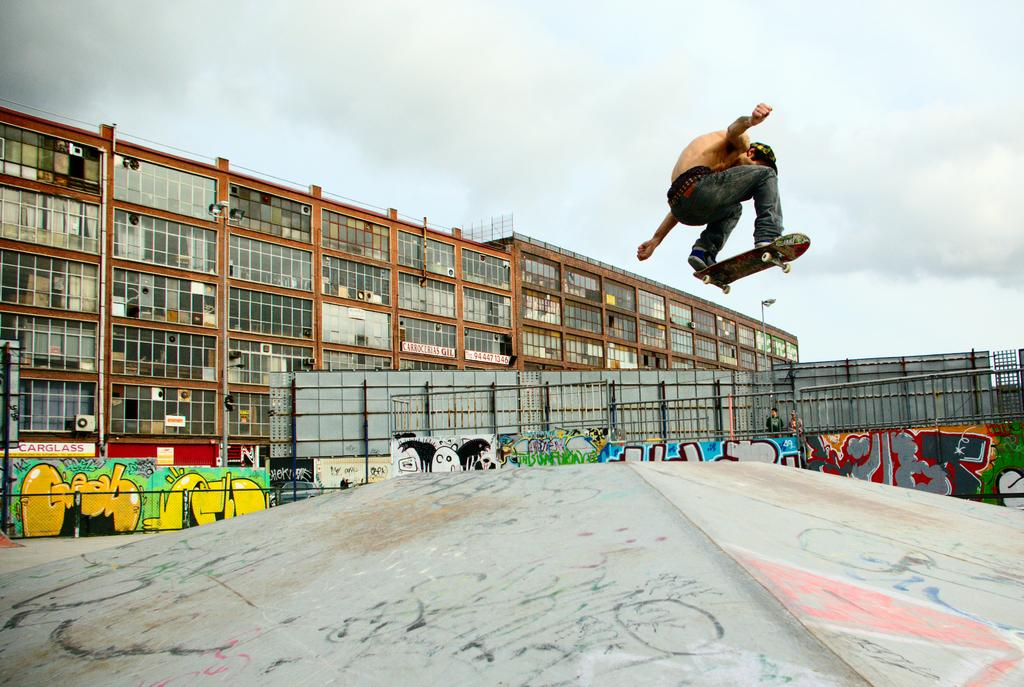Who is the main subject in the image? There is a boy in the image. What is the boy doing in the image? The boy is skateboarding. What can be seen in the center of the image? There are posters in the center of the image. What is visible in the background of the image? There are buildings in the background of the image. What degree does the boy have in the image? There is no information about the boy's degree in the image. What type of linen is draped over the skateboard in the image? There is no linen present in the image. 